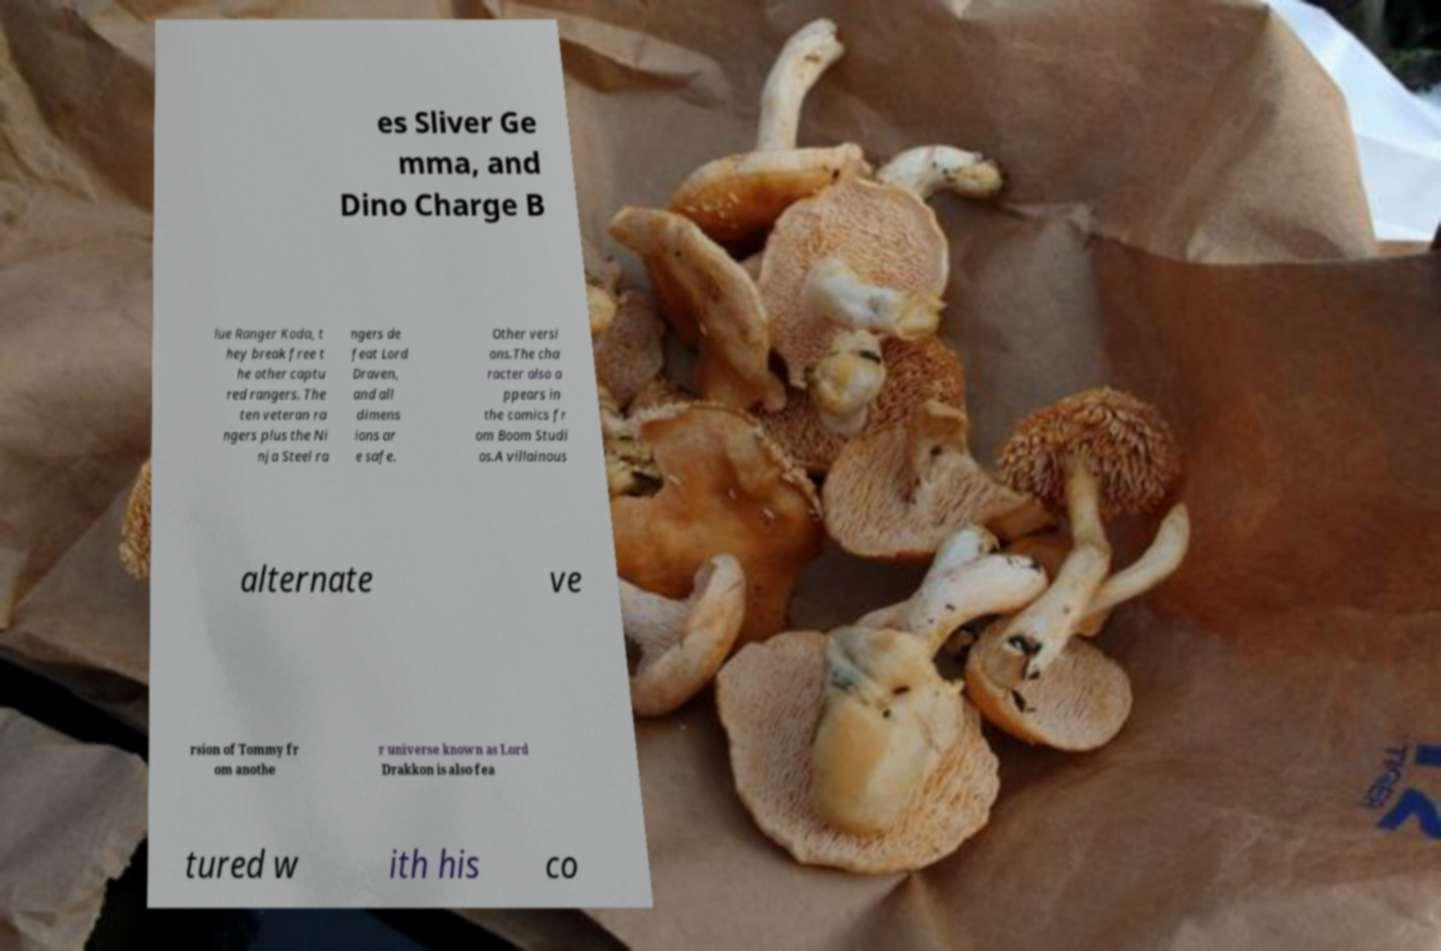Could you extract and type out the text from this image? es Sliver Ge mma, and Dino Charge B lue Ranger Koda, t hey break free t he other captu red rangers. The ten veteran ra ngers plus the Ni nja Steel ra ngers de feat Lord Draven, and all dimens ions ar e safe. Other versi ons.The cha racter also a ppears in the comics fr om Boom Studi os.A villainous alternate ve rsion of Tommy fr om anothe r universe known as Lord Drakkon is also fea tured w ith his co 